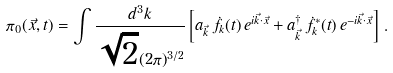Convert formula to latex. <formula><loc_0><loc_0><loc_500><loc_500>\pi _ { 0 } ( \vec { x } , t ) = \int \frac { d ^ { 3 } k } { \sqrt { 2 } ( 2 \pi ) ^ { 3 / 2 } } \left [ a _ { \vec { k } } \, { \dot { f } } _ { k } ( t ) \, e ^ { i \vec { k } \cdot \vec { x } } + a ^ { \dagger } _ { \vec { k } } \, { \dot { f } } ^ { * } _ { k } ( t ) \, e ^ { - i \vec { k } \cdot \vec { x } } \right ] \, .</formula> 